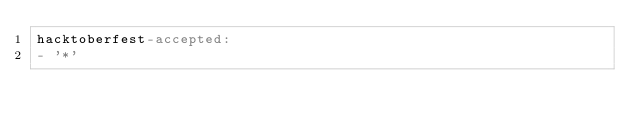<code> <loc_0><loc_0><loc_500><loc_500><_YAML_>hacktoberfest-accepted:
- '*'
</code> 